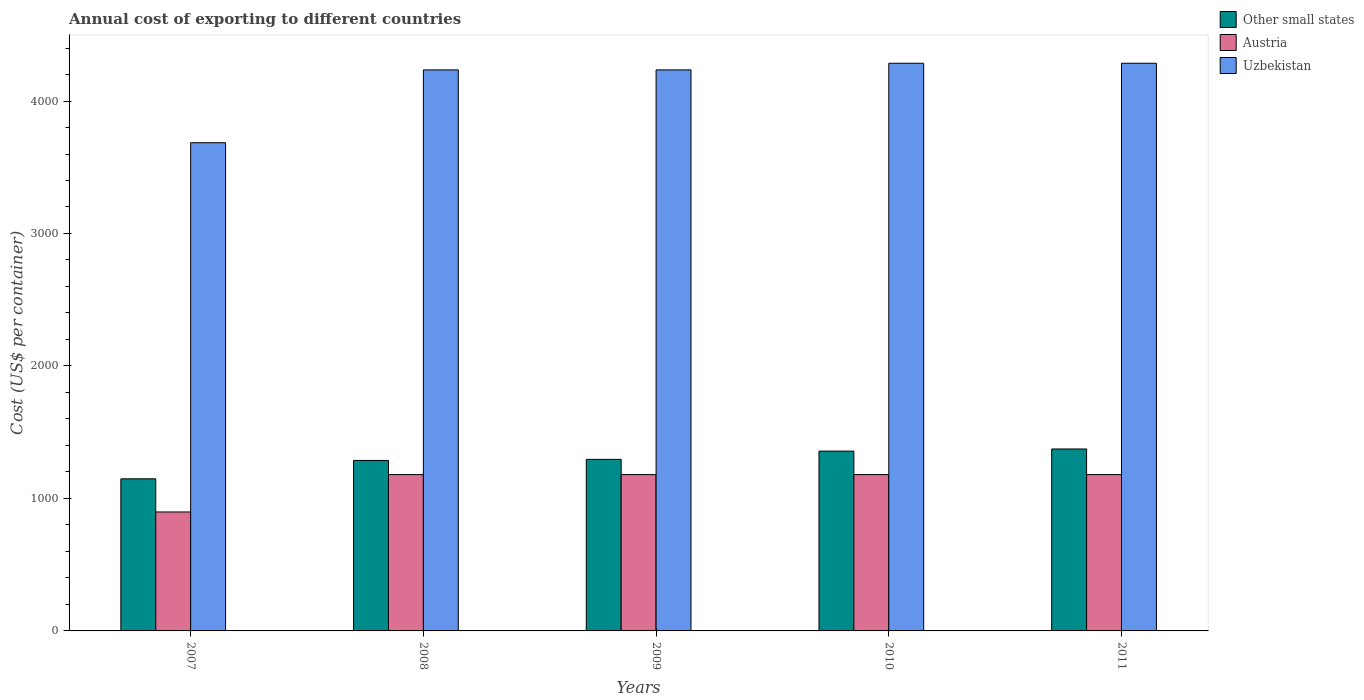How many bars are there on the 4th tick from the left?
Make the answer very short. 3. How many bars are there on the 4th tick from the right?
Keep it short and to the point. 3. In how many cases, is the number of bars for a given year not equal to the number of legend labels?
Provide a short and direct response. 0. What is the total annual cost of exporting in Austria in 2009?
Your answer should be compact. 1180. Across all years, what is the maximum total annual cost of exporting in Austria?
Make the answer very short. 1180. Across all years, what is the minimum total annual cost of exporting in Other small states?
Provide a succinct answer. 1148.28. In which year was the total annual cost of exporting in Uzbekistan maximum?
Provide a succinct answer. 2010. In which year was the total annual cost of exporting in Uzbekistan minimum?
Give a very brief answer. 2007. What is the total total annual cost of exporting in Uzbekistan in the graph?
Provide a succinct answer. 2.07e+04. What is the difference between the total annual cost of exporting in Uzbekistan in 2009 and that in 2011?
Provide a short and direct response. -50. What is the difference between the total annual cost of exporting in Uzbekistan in 2011 and the total annual cost of exporting in Other small states in 2007?
Your response must be concise. 3136.72. What is the average total annual cost of exporting in Uzbekistan per year?
Ensure brevity in your answer.  4145. In the year 2008, what is the difference between the total annual cost of exporting in Uzbekistan and total annual cost of exporting in Other small states?
Your answer should be compact. 2948.11. What is the ratio of the total annual cost of exporting in Uzbekistan in 2009 to that in 2010?
Give a very brief answer. 0.99. Is the total annual cost of exporting in Austria in 2007 less than that in 2011?
Offer a terse response. Yes. Is the difference between the total annual cost of exporting in Uzbekistan in 2009 and 2010 greater than the difference between the total annual cost of exporting in Other small states in 2009 and 2010?
Offer a very short reply. Yes. What is the difference between the highest and the second highest total annual cost of exporting in Other small states?
Make the answer very short. 16. What is the difference between the highest and the lowest total annual cost of exporting in Austria?
Give a very brief answer. 282. Is the sum of the total annual cost of exporting in Austria in 2008 and 2009 greater than the maximum total annual cost of exporting in Uzbekistan across all years?
Your response must be concise. No. What does the 1st bar from the right in 2011 represents?
Make the answer very short. Uzbekistan. Are all the bars in the graph horizontal?
Provide a succinct answer. No. How many years are there in the graph?
Provide a succinct answer. 5. Are the values on the major ticks of Y-axis written in scientific E-notation?
Offer a very short reply. No. Does the graph contain grids?
Ensure brevity in your answer.  No. What is the title of the graph?
Offer a very short reply. Annual cost of exporting to different countries. Does "Latvia" appear as one of the legend labels in the graph?
Provide a short and direct response. No. What is the label or title of the Y-axis?
Offer a terse response. Cost (US$ per container). What is the Cost (US$ per container) in Other small states in 2007?
Make the answer very short. 1148.28. What is the Cost (US$ per container) of Austria in 2007?
Offer a very short reply. 898. What is the Cost (US$ per container) in Uzbekistan in 2007?
Provide a succinct answer. 3685. What is the Cost (US$ per container) in Other small states in 2008?
Your answer should be compact. 1286.89. What is the Cost (US$ per container) in Austria in 2008?
Keep it short and to the point. 1180. What is the Cost (US$ per container) in Uzbekistan in 2008?
Ensure brevity in your answer.  4235. What is the Cost (US$ per container) in Other small states in 2009?
Your response must be concise. 1295. What is the Cost (US$ per container) in Austria in 2009?
Keep it short and to the point. 1180. What is the Cost (US$ per container) in Uzbekistan in 2009?
Make the answer very short. 4235. What is the Cost (US$ per container) of Other small states in 2010?
Keep it short and to the point. 1357.39. What is the Cost (US$ per container) of Austria in 2010?
Your answer should be compact. 1180. What is the Cost (US$ per container) of Uzbekistan in 2010?
Offer a very short reply. 4285. What is the Cost (US$ per container) in Other small states in 2011?
Offer a terse response. 1373.39. What is the Cost (US$ per container) in Austria in 2011?
Provide a succinct answer. 1180. What is the Cost (US$ per container) in Uzbekistan in 2011?
Offer a very short reply. 4285. Across all years, what is the maximum Cost (US$ per container) in Other small states?
Your response must be concise. 1373.39. Across all years, what is the maximum Cost (US$ per container) of Austria?
Provide a short and direct response. 1180. Across all years, what is the maximum Cost (US$ per container) of Uzbekistan?
Offer a terse response. 4285. Across all years, what is the minimum Cost (US$ per container) in Other small states?
Offer a very short reply. 1148.28. Across all years, what is the minimum Cost (US$ per container) of Austria?
Make the answer very short. 898. Across all years, what is the minimum Cost (US$ per container) of Uzbekistan?
Offer a terse response. 3685. What is the total Cost (US$ per container) in Other small states in the graph?
Offer a very short reply. 6460.94. What is the total Cost (US$ per container) of Austria in the graph?
Your response must be concise. 5618. What is the total Cost (US$ per container) of Uzbekistan in the graph?
Your response must be concise. 2.07e+04. What is the difference between the Cost (US$ per container) of Other small states in 2007 and that in 2008?
Keep it short and to the point. -138.61. What is the difference between the Cost (US$ per container) in Austria in 2007 and that in 2008?
Offer a very short reply. -282. What is the difference between the Cost (US$ per container) of Uzbekistan in 2007 and that in 2008?
Provide a succinct answer. -550. What is the difference between the Cost (US$ per container) in Other small states in 2007 and that in 2009?
Provide a short and direct response. -146.72. What is the difference between the Cost (US$ per container) of Austria in 2007 and that in 2009?
Give a very brief answer. -282. What is the difference between the Cost (US$ per container) in Uzbekistan in 2007 and that in 2009?
Your response must be concise. -550. What is the difference between the Cost (US$ per container) in Other small states in 2007 and that in 2010?
Keep it short and to the point. -209.11. What is the difference between the Cost (US$ per container) of Austria in 2007 and that in 2010?
Provide a short and direct response. -282. What is the difference between the Cost (US$ per container) of Uzbekistan in 2007 and that in 2010?
Provide a short and direct response. -600. What is the difference between the Cost (US$ per container) in Other small states in 2007 and that in 2011?
Make the answer very short. -225.11. What is the difference between the Cost (US$ per container) of Austria in 2007 and that in 2011?
Offer a very short reply. -282. What is the difference between the Cost (US$ per container) in Uzbekistan in 2007 and that in 2011?
Offer a very short reply. -600. What is the difference between the Cost (US$ per container) of Other small states in 2008 and that in 2009?
Your answer should be very brief. -8.11. What is the difference between the Cost (US$ per container) in Austria in 2008 and that in 2009?
Your answer should be very brief. 0. What is the difference between the Cost (US$ per container) in Other small states in 2008 and that in 2010?
Offer a terse response. -70.5. What is the difference between the Cost (US$ per container) of Austria in 2008 and that in 2010?
Give a very brief answer. 0. What is the difference between the Cost (US$ per container) in Uzbekistan in 2008 and that in 2010?
Ensure brevity in your answer.  -50. What is the difference between the Cost (US$ per container) of Other small states in 2008 and that in 2011?
Keep it short and to the point. -86.5. What is the difference between the Cost (US$ per container) of Austria in 2008 and that in 2011?
Provide a succinct answer. 0. What is the difference between the Cost (US$ per container) of Uzbekistan in 2008 and that in 2011?
Offer a very short reply. -50. What is the difference between the Cost (US$ per container) of Other small states in 2009 and that in 2010?
Give a very brief answer. -62.39. What is the difference between the Cost (US$ per container) of Other small states in 2009 and that in 2011?
Make the answer very short. -78.39. What is the difference between the Cost (US$ per container) in Other small states in 2010 and that in 2011?
Make the answer very short. -16. What is the difference between the Cost (US$ per container) in Austria in 2010 and that in 2011?
Ensure brevity in your answer.  0. What is the difference between the Cost (US$ per container) in Other small states in 2007 and the Cost (US$ per container) in Austria in 2008?
Keep it short and to the point. -31.72. What is the difference between the Cost (US$ per container) of Other small states in 2007 and the Cost (US$ per container) of Uzbekistan in 2008?
Give a very brief answer. -3086.72. What is the difference between the Cost (US$ per container) in Austria in 2007 and the Cost (US$ per container) in Uzbekistan in 2008?
Your answer should be very brief. -3337. What is the difference between the Cost (US$ per container) of Other small states in 2007 and the Cost (US$ per container) of Austria in 2009?
Provide a short and direct response. -31.72. What is the difference between the Cost (US$ per container) in Other small states in 2007 and the Cost (US$ per container) in Uzbekistan in 2009?
Make the answer very short. -3086.72. What is the difference between the Cost (US$ per container) in Austria in 2007 and the Cost (US$ per container) in Uzbekistan in 2009?
Your answer should be compact. -3337. What is the difference between the Cost (US$ per container) of Other small states in 2007 and the Cost (US$ per container) of Austria in 2010?
Give a very brief answer. -31.72. What is the difference between the Cost (US$ per container) of Other small states in 2007 and the Cost (US$ per container) of Uzbekistan in 2010?
Provide a succinct answer. -3136.72. What is the difference between the Cost (US$ per container) of Austria in 2007 and the Cost (US$ per container) of Uzbekistan in 2010?
Ensure brevity in your answer.  -3387. What is the difference between the Cost (US$ per container) in Other small states in 2007 and the Cost (US$ per container) in Austria in 2011?
Provide a succinct answer. -31.72. What is the difference between the Cost (US$ per container) in Other small states in 2007 and the Cost (US$ per container) in Uzbekistan in 2011?
Provide a succinct answer. -3136.72. What is the difference between the Cost (US$ per container) of Austria in 2007 and the Cost (US$ per container) of Uzbekistan in 2011?
Provide a short and direct response. -3387. What is the difference between the Cost (US$ per container) in Other small states in 2008 and the Cost (US$ per container) in Austria in 2009?
Provide a succinct answer. 106.89. What is the difference between the Cost (US$ per container) of Other small states in 2008 and the Cost (US$ per container) of Uzbekistan in 2009?
Offer a very short reply. -2948.11. What is the difference between the Cost (US$ per container) of Austria in 2008 and the Cost (US$ per container) of Uzbekistan in 2009?
Your response must be concise. -3055. What is the difference between the Cost (US$ per container) of Other small states in 2008 and the Cost (US$ per container) of Austria in 2010?
Your answer should be very brief. 106.89. What is the difference between the Cost (US$ per container) of Other small states in 2008 and the Cost (US$ per container) of Uzbekistan in 2010?
Give a very brief answer. -2998.11. What is the difference between the Cost (US$ per container) of Austria in 2008 and the Cost (US$ per container) of Uzbekistan in 2010?
Your answer should be compact. -3105. What is the difference between the Cost (US$ per container) of Other small states in 2008 and the Cost (US$ per container) of Austria in 2011?
Give a very brief answer. 106.89. What is the difference between the Cost (US$ per container) in Other small states in 2008 and the Cost (US$ per container) in Uzbekistan in 2011?
Your response must be concise. -2998.11. What is the difference between the Cost (US$ per container) in Austria in 2008 and the Cost (US$ per container) in Uzbekistan in 2011?
Ensure brevity in your answer.  -3105. What is the difference between the Cost (US$ per container) in Other small states in 2009 and the Cost (US$ per container) in Austria in 2010?
Offer a terse response. 115. What is the difference between the Cost (US$ per container) in Other small states in 2009 and the Cost (US$ per container) in Uzbekistan in 2010?
Make the answer very short. -2990. What is the difference between the Cost (US$ per container) in Austria in 2009 and the Cost (US$ per container) in Uzbekistan in 2010?
Keep it short and to the point. -3105. What is the difference between the Cost (US$ per container) in Other small states in 2009 and the Cost (US$ per container) in Austria in 2011?
Provide a short and direct response. 115. What is the difference between the Cost (US$ per container) of Other small states in 2009 and the Cost (US$ per container) of Uzbekistan in 2011?
Offer a very short reply. -2990. What is the difference between the Cost (US$ per container) in Austria in 2009 and the Cost (US$ per container) in Uzbekistan in 2011?
Your response must be concise. -3105. What is the difference between the Cost (US$ per container) of Other small states in 2010 and the Cost (US$ per container) of Austria in 2011?
Offer a terse response. 177.39. What is the difference between the Cost (US$ per container) of Other small states in 2010 and the Cost (US$ per container) of Uzbekistan in 2011?
Provide a short and direct response. -2927.61. What is the difference between the Cost (US$ per container) of Austria in 2010 and the Cost (US$ per container) of Uzbekistan in 2011?
Ensure brevity in your answer.  -3105. What is the average Cost (US$ per container) of Other small states per year?
Provide a short and direct response. 1292.19. What is the average Cost (US$ per container) in Austria per year?
Offer a very short reply. 1123.6. What is the average Cost (US$ per container) in Uzbekistan per year?
Offer a terse response. 4145. In the year 2007, what is the difference between the Cost (US$ per container) of Other small states and Cost (US$ per container) of Austria?
Provide a short and direct response. 250.28. In the year 2007, what is the difference between the Cost (US$ per container) of Other small states and Cost (US$ per container) of Uzbekistan?
Your response must be concise. -2536.72. In the year 2007, what is the difference between the Cost (US$ per container) in Austria and Cost (US$ per container) in Uzbekistan?
Your response must be concise. -2787. In the year 2008, what is the difference between the Cost (US$ per container) of Other small states and Cost (US$ per container) of Austria?
Make the answer very short. 106.89. In the year 2008, what is the difference between the Cost (US$ per container) in Other small states and Cost (US$ per container) in Uzbekistan?
Provide a succinct answer. -2948.11. In the year 2008, what is the difference between the Cost (US$ per container) in Austria and Cost (US$ per container) in Uzbekistan?
Your answer should be very brief. -3055. In the year 2009, what is the difference between the Cost (US$ per container) of Other small states and Cost (US$ per container) of Austria?
Provide a succinct answer. 115. In the year 2009, what is the difference between the Cost (US$ per container) in Other small states and Cost (US$ per container) in Uzbekistan?
Ensure brevity in your answer.  -2940. In the year 2009, what is the difference between the Cost (US$ per container) of Austria and Cost (US$ per container) of Uzbekistan?
Your answer should be compact. -3055. In the year 2010, what is the difference between the Cost (US$ per container) of Other small states and Cost (US$ per container) of Austria?
Give a very brief answer. 177.39. In the year 2010, what is the difference between the Cost (US$ per container) in Other small states and Cost (US$ per container) in Uzbekistan?
Offer a very short reply. -2927.61. In the year 2010, what is the difference between the Cost (US$ per container) in Austria and Cost (US$ per container) in Uzbekistan?
Provide a succinct answer. -3105. In the year 2011, what is the difference between the Cost (US$ per container) of Other small states and Cost (US$ per container) of Austria?
Keep it short and to the point. 193.39. In the year 2011, what is the difference between the Cost (US$ per container) in Other small states and Cost (US$ per container) in Uzbekistan?
Make the answer very short. -2911.61. In the year 2011, what is the difference between the Cost (US$ per container) of Austria and Cost (US$ per container) of Uzbekistan?
Offer a very short reply. -3105. What is the ratio of the Cost (US$ per container) of Other small states in 2007 to that in 2008?
Ensure brevity in your answer.  0.89. What is the ratio of the Cost (US$ per container) of Austria in 2007 to that in 2008?
Provide a succinct answer. 0.76. What is the ratio of the Cost (US$ per container) of Uzbekistan in 2007 to that in 2008?
Keep it short and to the point. 0.87. What is the ratio of the Cost (US$ per container) of Other small states in 2007 to that in 2009?
Offer a terse response. 0.89. What is the ratio of the Cost (US$ per container) in Austria in 2007 to that in 2009?
Provide a short and direct response. 0.76. What is the ratio of the Cost (US$ per container) of Uzbekistan in 2007 to that in 2009?
Your answer should be very brief. 0.87. What is the ratio of the Cost (US$ per container) in Other small states in 2007 to that in 2010?
Ensure brevity in your answer.  0.85. What is the ratio of the Cost (US$ per container) in Austria in 2007 to that in 2010?
Give a very brief answer. 0.76. What is the ratio of the Cost (US$ per container) of Uzbekistan in 2007 to that in 2010?
Make the answer very short. 0.86. What is the ratio of the Cost (US$ per container) in Other small states in 2007 to that in 2011?
Provide a succinct answer. 0.84. What is the ratio of the Cost (US$ per container) in Austria in 2007 to that in 2011?
Your response must be concise. 0.76. What is the ratio of the Cost (US$ per container) of Uzbekistan in 2007 to that in 2011?
Give a very brief answer. 0.86. What is the ratio of the Cost (US$ per container) in Other small states in 2008 to that in 2009?
Provide a short and direct response. 0.99. What is the ratio of the Cost (US$ per container) in Austria in 2008 to that in 2009?
Your answer should be compact. 1. What is the ratio of the Cost (US$ per container) of Other small states in 2008 to that in 2010?
Keep it short and to the point. 0.95. What is the ratio of the Cost (US$ per container) of Uzbekistan in 2008 to that in 2010?
Make the answer very short. 0.99. What is the ratio of the Cost (US$ per container) in Other small states in 2008 to that in 2011?
Provide a succinct answer. 0.94. What is the ratio of the Cost (US$ per container) in Austria in 2008 to that in 2011?
Offer a very short reply. 1. What is the ratio of the Cost (US$ per container) of Uzbekistan in 2008 to that in 2011?
Your answer should be compact. 0.99. What is the ratio of the Cost (US$ per container) in Other small states in 2009 to that in 2010?
Ensure brevity in your answer.  0.95. What is the ratio of the Cost (US$ per container) in Uzbekistan in 2009 to that in 2010?
Ensure brevity in your answer.  0.99. What is the ratio of the Cost (US$ per container) of Other small states in 2009 to that in 2011?
Provide a short and direct response. 0.94. What is the ratio of the Cost (US$ per container) in Austria in 2009 to that in 2011?
Provide a succinct answer. 1. What is the ratio of the Cost (US$ per container) of Uzbekistan in 2009 to that in 2011?
Ensure brevity in your answer.  0.99. What is the ratio of the Cost (US$ per container) of Other small states in 2010 to that in 2011?
Provide a short and direct response. 0.99. What is the difference between the highest and the second highest Cost (US$ per container) in Uzbekistan?
Offer a terse response. 0. What is the difference between the highest and the lowest Cost (US$ per container) of Other small states?
Offer a very short reply. 225.11. What is the difference between the highest and the lowest Cost (US$ per container) in Austria?
Offer a terse response. 282. What is the difference between the highest and the lowest Cost (US$ per container) of Uzbekistan?
Provide a short and direct response. 600. 